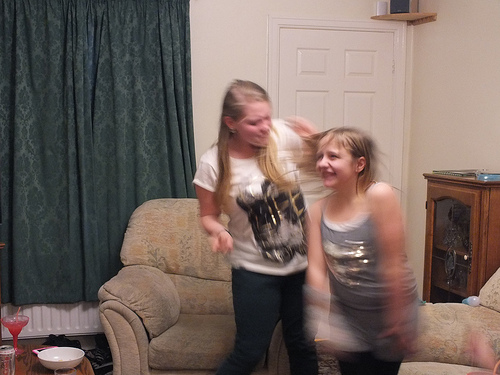<image>
Can you confirm if the woman is on the chair? No. The woman is not positioned on the chair. They may be near each other, but the woman is not supported by or resting on top of the chair. Where is the shelf in relation to the corner? Is it in the corner? Yes. The shelf is contained within or inside the corner, showing a containment relationship. Is there a girl in front of the girl? Yes. The girl is positioned in front of the girl, appearing closer to the camera viewpoint. 